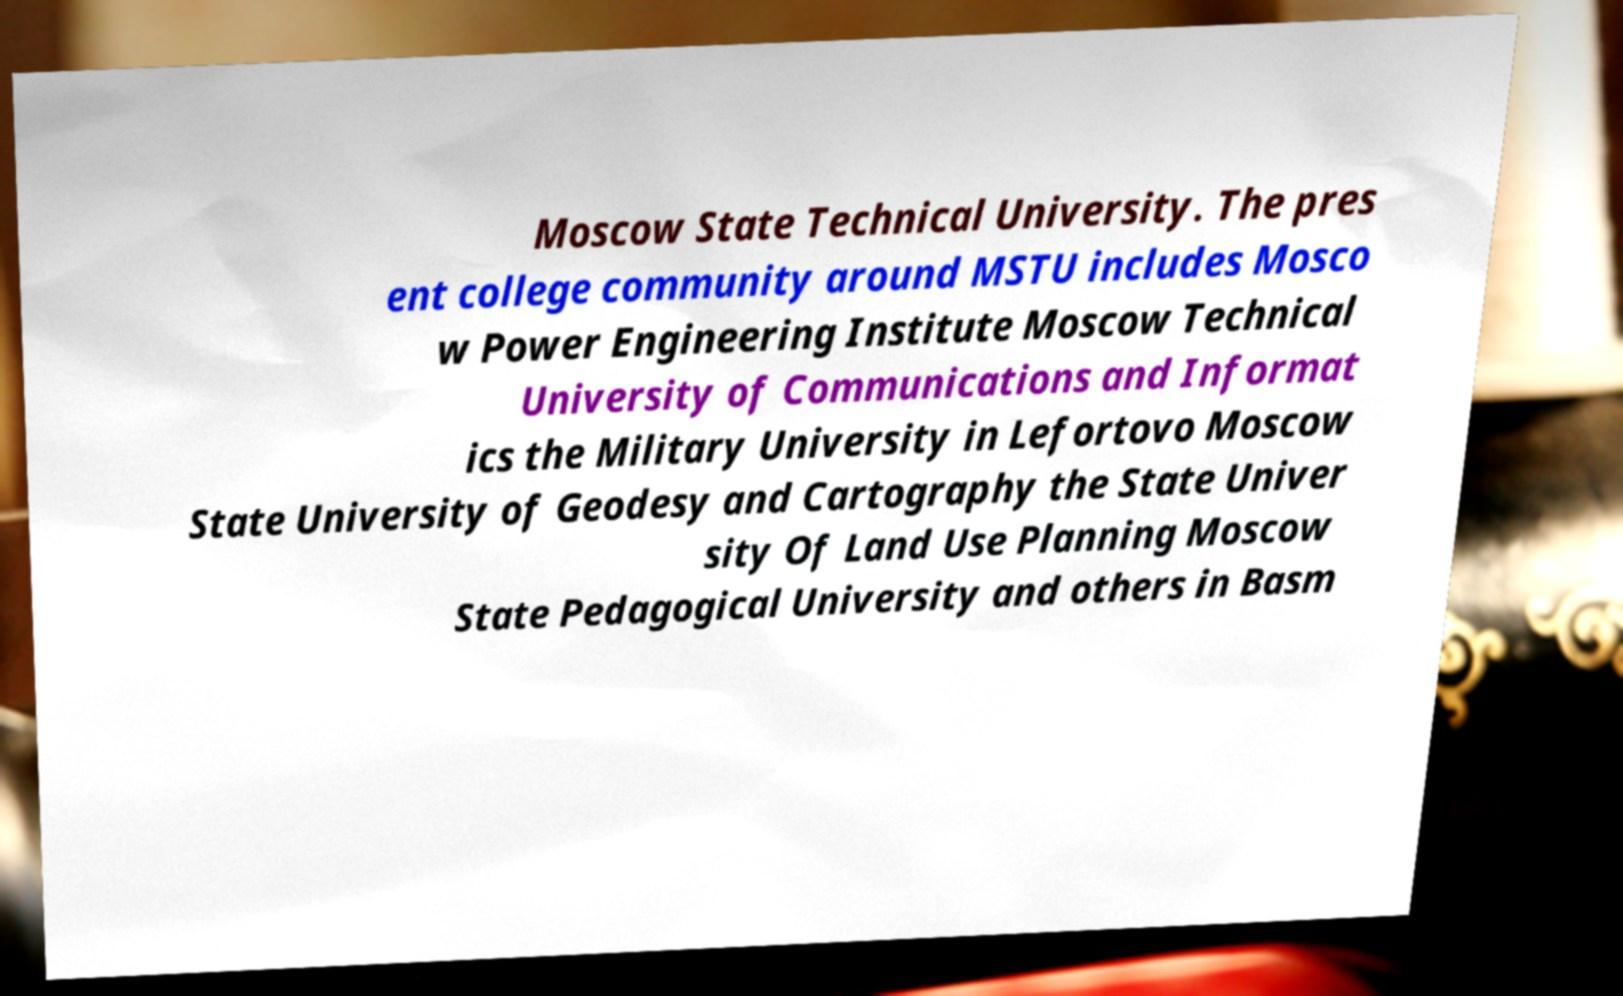Please read and relay the text visible in this image. What does it say? Moscow State Technical University. The pres ent college community around MSTU includes Mosco w Power Engineering Institute Moscow Technical University of Communications and Informat ics the Military University in Lefortovo Moscow State University of Geodesy and Cartography the State Univer sity Of Land Use Planning Moscow State Pedagogical University and others in Basm 